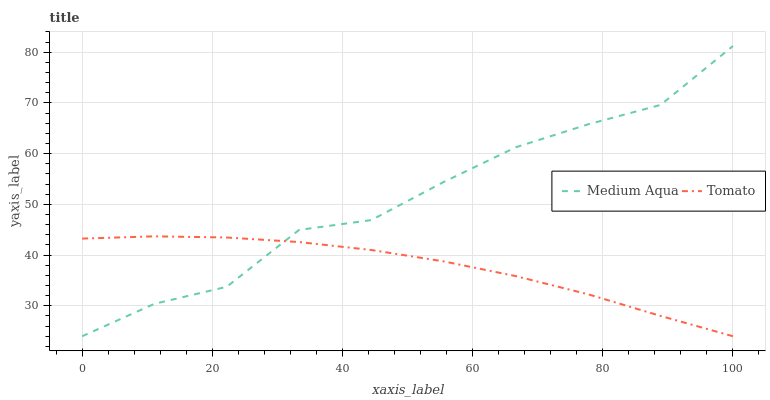Does Tomato have the minimum area under the curve?
Answer yes or no. Yes. Does Medium Aqua have the maximum area under the curve?
Answer yes or no. Yes. Does Medium Aqua have the minimum area under the curve?
Answer yes or no. No. Is Tomato the smoothest?
Answer yes or no. Yes. Is Medium Aqua the roughest?
Answer yes or no. Yes. Is Medium Aqua the smoothest?
Answer yes or no. No. 